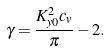<formula> <loc_0><loc_0><loc_500><loc_500>\gamma = { \frac { K _ { y 0 } ^ { 2 } c _ { v } } { \pi } } - 2 .</formula> 